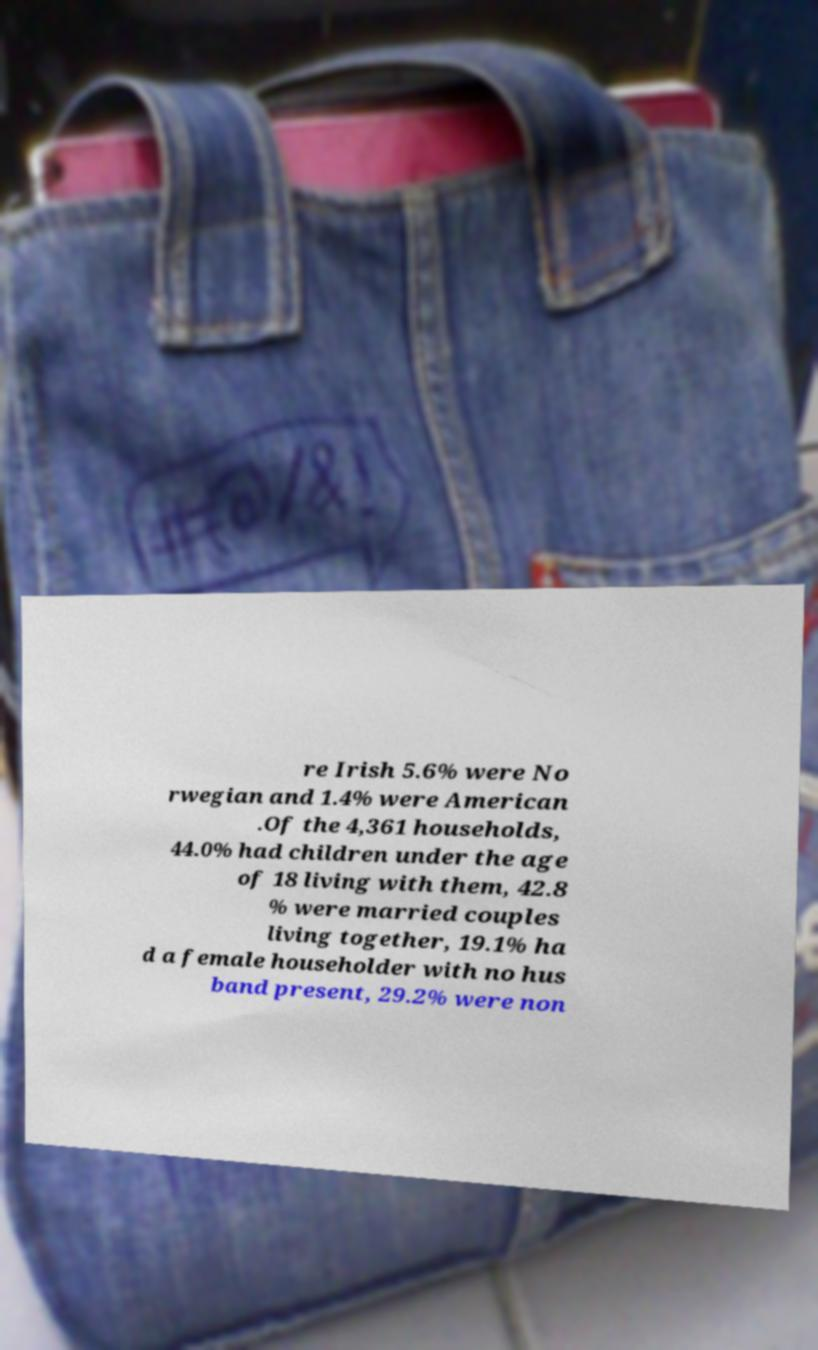Can you read and provide the text displayed in the image?This photo seems to have some interesting text. Can you extract and type it out for me? re Irish 5.6% were No rwegian and 1.4% were American .Of the 4,361 households, 44.0% had children under the age of 18 living with them, 42.8 % were married couples living together, 19.1% ha d a female householder with no hus band present, 29.2% were non 